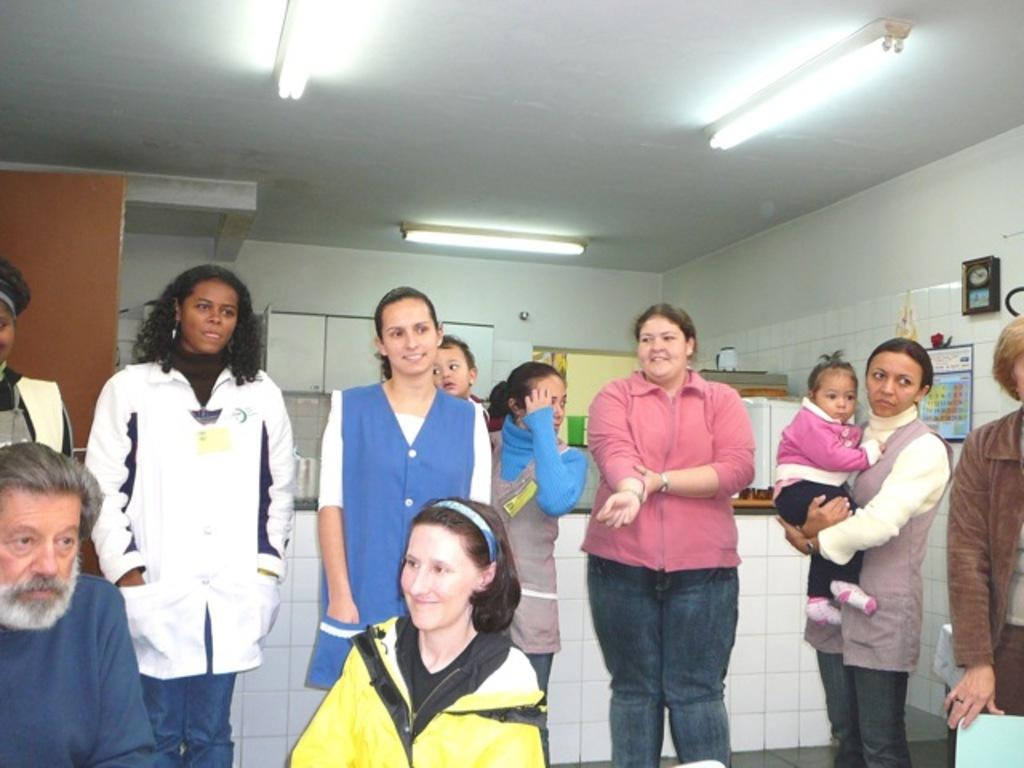How many people are in the image? There are people in the image, but the exact number is not specified. What is the woman in the image doing? The woman is carrying a baby in the image. What can be seen on the wall in the image? There is a clock, a calendar, and a cupboard on the wall in the image. What is on the platform in the image? There are things on a platform in the image, but their specific nature is not mentioned. What type of copy machine is visible in the image? There is no copy machine present in the image. What is the woman feeding the baby in the image? The facts do not mention anything about the woman feeding the baby, so we cannot answer this question. 